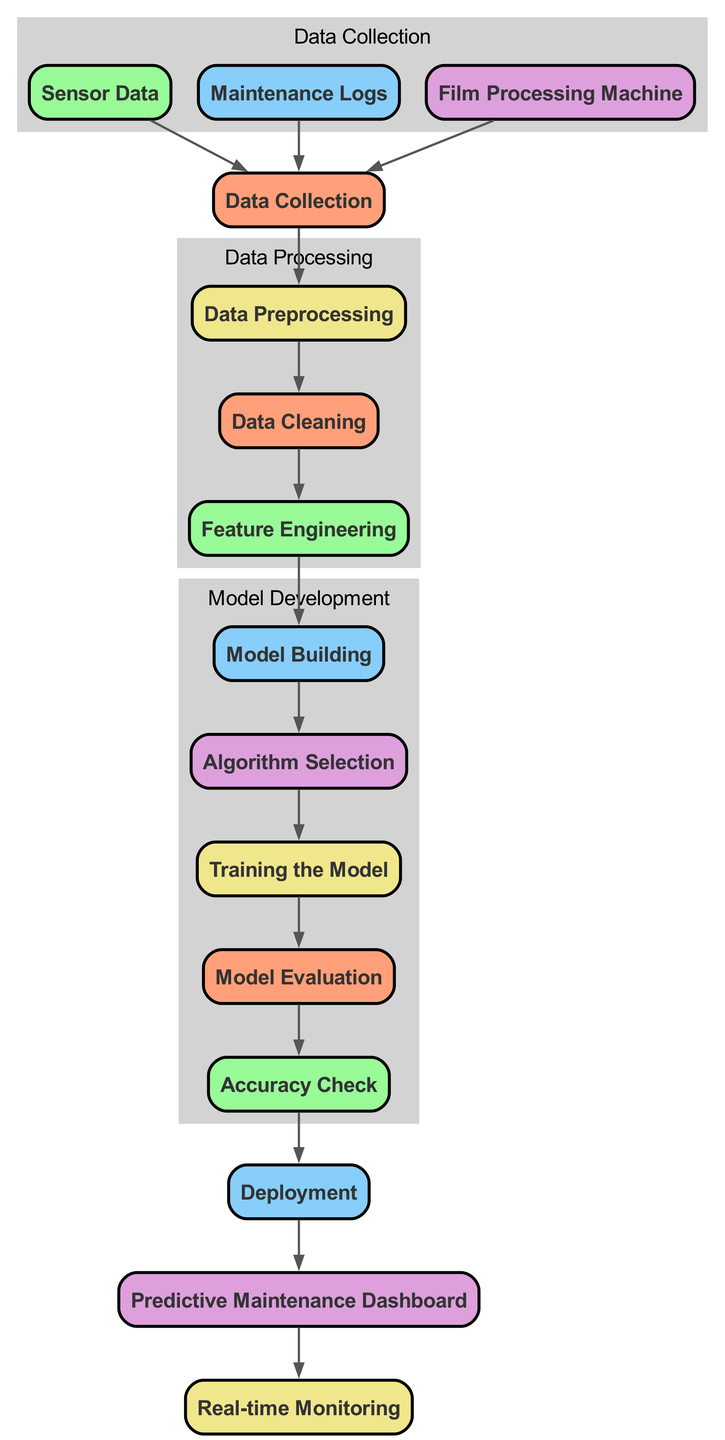What is the first node in the diagram? The diagram starts with the "Data Collection" node, which indicates the initial phase of the predictive maintenance process. This can be observed as the top node of the flowchart, where all information begins.
Answer: Data Collection How many nodes are there in total? By counting each unique labeled node in the diagram, we see there are 14 nodes listed, each representing a different step or component in the predictive maintenance process.
Answer: 14 What node follows "Data Cleaning"? The node that comes directly after "Data Cleaning" is "Feature Engineering." This can be determined by tracing the edges leading from "Data Cleaning" to the next node in the flow.
Answer: Feature Engineering Which nodes belong to the "Data Processing" cluster? The nodes included in the "Data Processing" cluster are "Data Preprocessing," "Data Cleaning," and "Feature Engineering." This group is distinctly labeled in the diagram and encompasses all steps involved in processing data before model building.
Answer: Data Preprocessing, Data Cleaning, Feature Engineering What type of model is being built after feature engineering? After feature engineering, the process leads to "Model Building," which indicates that the next step involves creating a predictive model based on the prepared features. This can be confirmed by following the flow to determine what occurs next in the diagram.
Answer: Model Building What is the last step in the process? The final step indicated in the diagram is "Real-time Monitoring." This shows that once the entire process of predictive maintenance has been completed, ongoing monitoring is the end goal, ensuring system reliability and performance continuously.
Answer: Real-time Monitoring Which nodes collect data in the process? The nodes responsible for data collection are "Sensor Data," "Maintenance Logs," and "Processing Machine." All these nodes are grouped under the "Data Collection" section, emphasizing their role in gathering necessary data.
Answer: Sensor Data, Maintenance Logs, Processing Machine How does the "Predictive Maintenance Dashboard" relate to "Deployment"? The "Predictive Maintenance Dashboard" is dependent on "Deployment," as it is the step that follows deployment in the workflow. This indicates that after the model is deployed, the dashboard can then be used to visualize and interact with the predictive maintenance data.
Answer: Predictive Maintenance Dashboard What happens immediately after "Training the Model"? Immediately following "Training the Model" is "Model Evaluation." This step checks the trained model's effectiveness and ensures it meets the necessary performance metrics before moving to the next phase.
Answer: Model Evaluation 